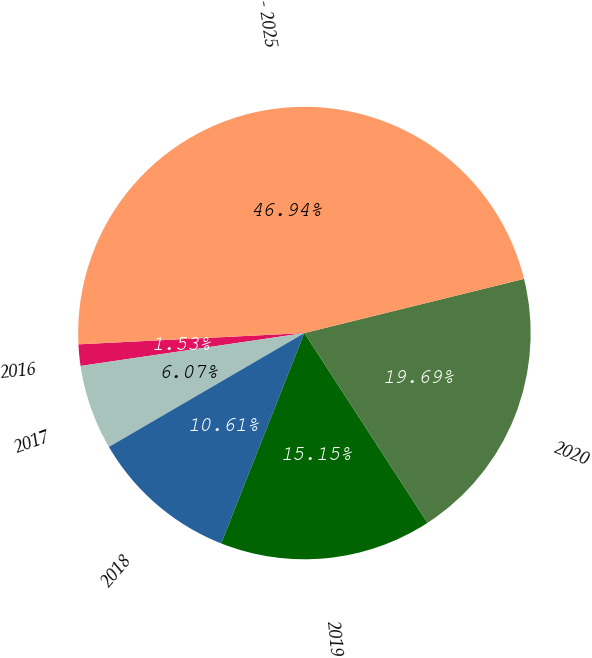Convert chart. <chart><loc_0><loc_0><loc_500><loc_500><pie_chart><fcel>2016<fcel>2017<fcel>2018<fcel>2019<fcel>2020<fcel>2021 - 2025<nl><fcel>1.53%<fcel>6.07%<fcel>10.61%<fcel>15.15%<fcel>19.69%<fcel>46.94%<nl></chart> 